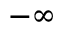Convert formula to latex. <formula><loc_0><loc_0><loc_500><loc_500>- \infty</formula> 